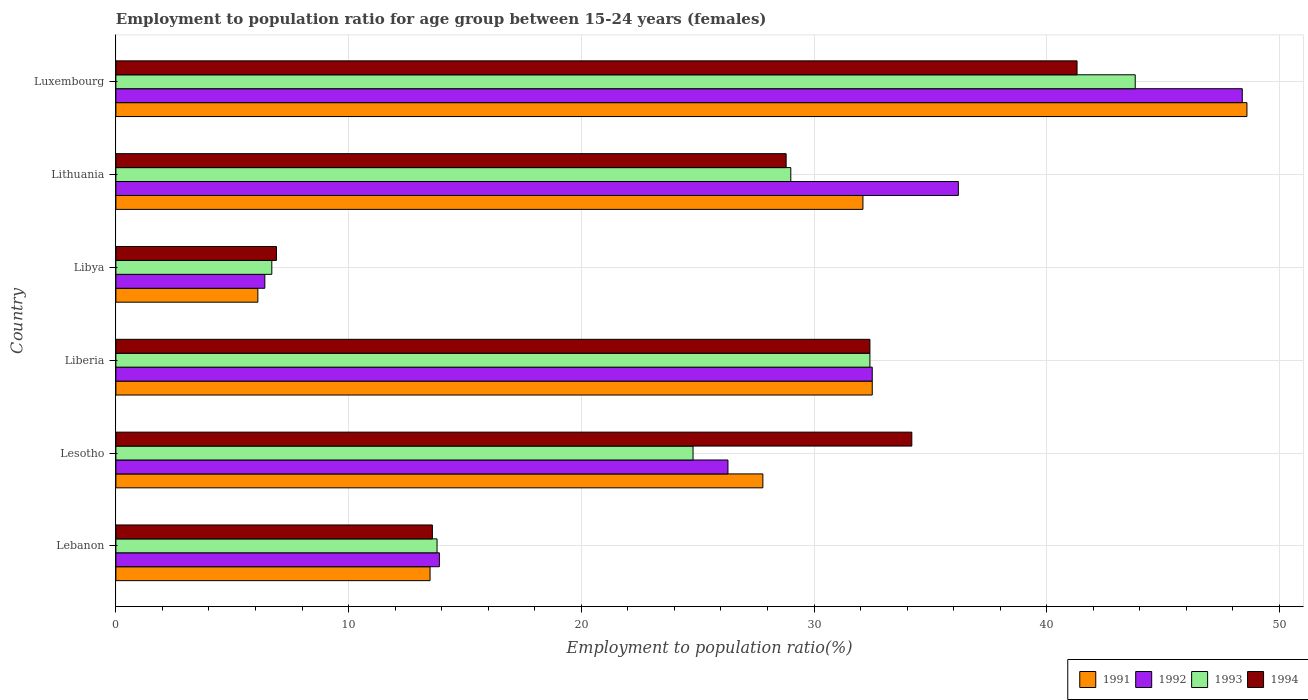How many different coloured bars are there?
Provide a short and direct response. 4. How many bars are there on the 1st tick from the top?
Your response must be concise. 4. What is the label of the 1st group of bars from the top?
Offer a very short reply. Luxembourg. In how many cases, is the number of bars for a given country not equal to the number of legend labels?
Keep it short and to the point. 0. What is the employment to population ratio in 1992 in Lebanon?
Ensure brevity in your answer.  13.9. Across all countries, what is the maximum employment to population ratio in 1993?
Your answer should be very brief. 43.8. Across all countries, what is the minimum employment to population ratio in 1991?
Ensure brevity in your answer.  6.1. In which country was the employment to population ratio in 1991 maximum?
Make the answer very short. Luxembourg. In which country was the employment to population ratio in 1992 minimum?
Your answer should be very brief. Libya. What is the total employment to population ratio in 1992 in the graph?
Give a very brief answer. 163.7. What is the difference between the employment to population ratio in 1994 in Lesotho and that in Lithuania?
Offer a very short reply. 5.4. What is the difference between the employment to population ratio in 1993 in Lesotho and the employment to population ratio in 1994 in Libya?
Keep it short and to the point. 17.9. What is the average employment to population ratio in 1991 per country?
Keep it short and to the point. 26.77. What is the ratio of the employment to population ratio in 1991 in Lebanon to that in Lesotho?
Keep it short and to the point. 0.49. What is the difference between the highest and the second highest employment to population ratio in 1992?
Provide a short and direct response. 12.2. What is the difference between the highest and the lowest employment to population ratio in 1992?
Make the answer very short. 42. In how many countries, is the employment to population ratio in 1991 greater than the average employment to population ratio in 1991 taken over all countries?
Provide a succinct answer. 4. Is the sum of the employment to population ratio in 1992 in Libya and Lithuania greater than the maximum employment to population ratio in 1994 across all countries?
Keep it short and to the point. Yes. What does the 2nd bar from the bottom in Lithuania represents?
Offer a very short reply. 1992. Is it the case that in every country, the sum of the employment to population ratio in 1991 and employment to population ratio in 1992 is greater than the employment to population ratio in 1994?
Your response must be concise. Yes. How many bars are there?
Ensure brevity in your answer.  24. Are all the bars in the graph horizontal?
Ensure brevity in your answer.  Yes. Are the values on the major ticks of X-axis written in scientific E-notation?
Ensure brevity in your answer.  No. Does the graph contain any zero values?
Provide a succinct answer. No. Where does the legend appear in the graph?
Your response must be concise. Bottom right. How many legend labels are there?
Offer a terse response. 4. What is the title of the graph?
Provide a succinct answer. Employment to population ratio for age group between 15-24 years (females). Does "2012" appear as one of the legend labels in the graph?
Your answer should be compact. No. What is the label or title of the Y-axis?
Give a very brief answer. Country. What is the Employment to population ratio(%) in 1991 in Lebanon?
Provide a short and direct response. 13.5. What is the Employment to population ratio(%) of 1992 in Lebanon?
Offer a very short reply. 13.9. What is the Employment to population ratio(%) in 1993 in Lebanon?
Give a very brief answer. 13.8. What is the Employment to population ratio(%) of 1994 in Lebanon?
Keep it short and to the point. 13.6. What is the Employment to population ratio(%) in 1991 in Lesotho?
Your answer should be compact. 27.8. What is the Employment to population ratio(%) of 1992 in Lesotho?
Offer a terse response. 26.3. What is the Employment to population ratio(%) in 1993 in Lesotho?
Your response must be concise. 24.8. What is the Employment to population ratio(%) of 1994 in Lesotho?
Your answer should be very brief. 34.2. What is the Employment to population ratio(%) in 1991 in Liberia?
Offer a terse response. 32.5. What is the Employment to population ratio(%) in 1992 in Liberia?
Give a very brief answer. 32.5. What is the Employment to population ratio(%) of 1993 in Liberia?
Keep it short and to the point. 32.4. What is the Employment to population ratio(%) in 1994 in Liberia?
Your response must be concise. 32.4. What is the Employment to population ratio(%) in 1991 in Libya?
Give a very brief answer. 6.1. What is the Employment to population ratio(%) in 1992 in Libya?
Ensure brevity in your answer.  6.4. What is the Employment to population ratio(%) of 1993 in Libya?
Your response must be concise. 6.7. What is the Employment to population ratio(%) in 1994 in Libya?
Provide a short and direct response. 6.9. What is the Employment to population ratio(%) in 1991 in Lithuania?
Keep it short and to the point. 32.1. What is the Employment to population ratio(%) of 1992 in Lithuania?
Offer a very short reply. 36.2. What is the Employment to population ratio(%) in 1993 in Lithuania?
Make the answer very short. 29. What is the Employment to population ratio(%) in 1994 in Lithuania?
Provide a succinct answer. 28.8. What is the Employment to population ratio(%) of 1991 in Luxembourg?
Your response must be concise. 48.6. What is the Employment to population ratio(%) in 1992 in Luxembourg?
Provide a succinct answer. 48.4. What is the Employment to population ratio(%) in 1993 in Luxembourg?
Keep it short and to the point. 43.8. What is the Employment to population ratio(%) of 1994 in Luxembourg?
Provide a short and direct response. 41.3. Across all countries, what is the maximum Employment to population ratio(%) in 1991?
Offer a very short reply. 48.6. Across all countries, what is the maximum Employment to population ratio(%) of 1992?
Provide a short and direct response. 48.4. Across all countries, what is the maximum Employment to population ratio(%) of 1993?
Make the answer very short. 43.8. Across all countries, what is the maximum Employment to population ratio(%) of 1994?
Your response must be concise. 41.3. Across all countries, what is the minimum Employment to population ratio(%) of 1991?
Give a very brief answer. 6.1. Across all countries, what is the minimum Employment to population ratio(%) in 1992?
Offer a very short reply. 6.4. Across all countries, what is the minimum Employment to population ratio(%) in 1993?
Make the answer very short. 6.7. Across all countries, what is the minimum Employment to population ratio(%) in 1994?
Provide a succinct answer. 6.9. What is the total Employment to population ratio(%) in 1991 in the graph?
Give a very brief answer. 160.6. What is the total Employment to population ratio(%) in 1992 in the graph?
Offer a terse response. 163.7. What is the total Employment to population ratio(%) of 1993 in the graph?
Your answer should be compact. 150.5. What is the total Employment to population ratio(%) of 1994 in the graph?
Your answer should be very brief. 157.2. What is the difference between the Employment to population ratio(%) of 1991 in Lebanon and that in Lesotho?
Your response must be concise. -14.3. What is the difference between the Employment to population ratio(%) in 1993 in Lebanon and that in Lesotho?
Offer a terse response. -11. What is the difference between the Employment to population ratio(%) of 1994 in Lebanon and that in Lesotho?
Give a very brief answer. -20.6. What is the difference between the Employment to population ratio(%) in 1992 in Lebanon and that in Liberia?
Keep it short and to the point. -18.6. What is the difference between the Employment to population ratio(%) in 1993 in Lebanon and that in Liberia?
Provide a short and direct response. -18.6. What is the difference between the Employment to population ratio(%) of 1994 in Lebanon and that in Liberia?
Offer a very short reply. -18.8. What is the difference between the Employment to population ratio(%) in 1993 in Lebanon and that in Libya?
Ensure brevity in your answer.  7.1. What is the difference between the Employment to population ratio(%) of 1991 in Lebanon and that in Lithuania?
Your answer should be compact. -18.6. What is the difference between the Employment to population ratio(%) in 1992 in Lebanon and that in Lithuania?
Your response must be concise. -22.3. What is the difference between the Employment to population ratio(%) in 1993 in Lebanon and that in Lithuania?
Offer a very short reply. -15.2. What is the difference between the Employment to population ratio(%) in 1994 in Lebanon and that in Lithuania?
Your answer should be compact. -15.2. What is the difference between the Employment to population ratio(%) of 1991 in Lebanon and that in Luxembourg?
Make the answer very short. -35.1. What is the difference between the Employment to population ratio(%) in 1992 in Lebanon and that in Luxembourg?
Your answer should be very brief. -34.5. What is the difference between the Employment to population ratio(%) in 1994 in Lebanon and that in Luxembourg?
Your response must be concise. -27.7. What is the difference between the Employment to population ratio(%) in 1991 in Lesotho and that in Libya?
Offer a terse response. 21.7. What is the difference between the Employment to population ratio(%) in 1992 in Lesotho and that in Libya?
Offer a very short reply. 19.9. What is the difference between the Employment to population ratio(%) of 1993 in Lesotho and that in Libya?
Your response must be concise. 18.1. What is the difference between the Employment to population ratio(%) in 1994 in Lesotho and that in Libya?
Your answer should be very brief. 27.3. What is the difference between the Employment to population ratio(%) of 1991 in Lesotho and that in Lithuania?
Your answer should be compact. -4.3. What is the difference between the Employment to population ratio(%) in 1992 in Lesotho and that in Lithuania?
Give a very brief answer. -9.9. What is the difference between the Employment to population ratio(%) in 1993 in Lesotho and that in Lithuania?
Your answer should be very brief. -4.2. What is the difference between the Employment to population ratio(%) of 1994 in Lesotho and that in Lithuania?
Provide a short and direct response. 5.4. What is the difference between the Employment to population ratio(%) in 1991 in Lesotho and that in Luxembourg?
Give a very brief answer. -20.8. What is the difference between the Employment to population ratio(%) of 1992 in Lesotho and that in Luxembourg?
Give a very brief answer. -22.1. What is the difference between the Employment to population ratio(%) in 1991 in Liberia and that in Libya?
Make the answer very short. 26.4. What is the difference between the Employment to population ratio(%) in 1992 in Liberia and that in Libya?
Your answer should be very brief. 26.1. What is the difference between the Employment to population ratio(%) in 1993 in Liberia and that in Libya?
Your response must be concise. 25.7. What is the difference between the Employment to population ratio(%) of 1991 in Liberia and that in Lithuania?
Offer a terse response. 0.4. What is the difference between the Employment to population ratio(%) of 1992 in Liberia and that in Lithuania?
Your response must be concise. -3.7. What is the difference between the Employment to population ratio(%) of 1994 in Liberia and that in Lithuania?
Keep it short and to the point. 3.6. What is the difference between the Employment to population ratio(%) in 1991 in Liberia and that in Luxembourg?
Your answer should be very brief. -16.1. What is the difference between the Employment to population ratio(%) of 1992 in Liberia and that in Luxembourg?
Your answer should be very brief. -15.9. What is the difference between the Employment to population ratio(%) of 1993 in Liberia and that in Luxembourg?
Give a very brief answer. -11.4. What is the difference between the Employment to population ratio(%) of 1991 in Libya and that in Lithuania?
Ensure brevity in your answer.  -26. What is the difference between the Employment to population ratio(%) of 1992 in Libya and that in Lithuania?
Make the answer very short. -29.8. What is the difference between the Employment to population ratio(%) of 1993 in Libya and that in Lithuania?
Offer a very short reply. -22.3. What is the difference between the Employment to population ratio(%) in 1994 in Libya and that in Lithuania?
Offer a terse response. -21.9. What is the difference between the Employment to population ratio(%) in 1991 in Libya and that in Luxembourg?
Keep it short and to the point. -42.5. What is the difference between the Employment to population ratio(%) in 1992 in Libya and that in Luxembourg?
Your answer should be very brief. -42. What is the difference between the Employment to population ratio(%) in 1993 in Libya and that in Luxembourg?
Your answer should be very brief. -37.1. What is the difference between the Employment to population ratio(%) in 1994 in Libya and that in Luxembourg?
Your answer should be very brief. -34.4. What is the difference between the Employment to population ratio(%) of 1991 in Lithuania and that in Luxembourg?
Give a very brief answer. -16.5. What is the difference between the Employment to population ratio(%) in 1993 in Lithuania and that in Luxembourg?
Keep it short and to the point. -14.8. What is the difference between the Employment to population ratio(%) of 1994 in Lithuania and that in Luxembourg?
Offer a very short reply. -12.5. What is the difference between the Employment to population ratio(%) in 1991 in Lebanon and the Employment to population ratio(%) in 1993 in Lesotho?
Your answer should be compact. -11.3. What is the difference between the Employment to population ratio(%) of 1991 in Lebanon and the Employment to population ratio(%) of 1994 in Lesotho?
Ensure brevity in your answer.  -20.7. What is the difference between the Employment to population ratio(%) in 1992 in Lebanon and the Employment to population ratio(%) in 1994 in Lesotho?
Your answer should be compact. -20.3. What is the difference between the Employment to population ratio(%) of 1993 in Lebanon and the Employment to population ratio(%) of 1994 in Lesotho?
Offer a terse response. -20.4. What is the difference between the Employment to population ratio(%) in 1991 in Lebanon and the Employment to population ratio(%) in 1993 in Liberia?
Ensure brevity in your answer.  -18.9. What is the difference between the Employment to population ratio(%) in 1991 in Lebanon and the Employment to population ratio(%) in 1994 in Liberia?
Your answer should be compact. -18.9. What is the difference between the Employment to population ratio(%) of 1992 in Lebanon and the Employment to population ratio(%) of 1993 in Liberia?
Your answer should be very brief. -18.5. What is the difference between the Employment to population ratio(%) of 1992 in Lebanon and the Employment to population ratio(%) of 1994 in Liberia?
Provide a succinct answer. -18.5. What is the difference between the Employment to population ratio(%) in 1993 in Lebanon and the Employment to population ratio(%) in 1994 in Liberia?
Provide a short and direct response. -18.6. What is the difference between the Employment to population ratio(%) in 1991 in Lebanon and the Employment to population ratio(%) in 1992 in Libya?
Offer a terse response. 7.1. What is the difference between the Employment to population ratio(%) in 1992 in Lebanon and the Employment to population ratio(%) in 1993 in Libya?
Give a very brief answer. 7.2. What is the difference between the Employment to population ratio(%) in 1992 in Lebanon and the Employment to population ratio(%) in 1994 in Libya?
Ensure brevity in your answer.  7. What is the difference between the Employment to population ratio(%) in 1991 in Lebanon and the Employment to population ratio(%) in 1992 in Lithuania?
Give a very brief answer. -22.7. What is the difference between the Employment to population ratio(%) in 1991 in Lebanon and the Employment to population ratio(%) in 1993 in Lithuania?
Give a very brief answer. -15.5. What is the difference between the Employment to population ratio(%) of 1991 in Lebanon and the Employment to population ratio(%) of 1994 in Lithuania?
Provide a succinct answer. -15.3. What is the difference between the Employment to population ratio(%) in 1992 in Lebanon and the Employment to population ratio(%) in 1993 in Lithuania?
Keep it short and to the point. -15.1. What is the difference between the Employment to population ratio(%) in 1992 in Lebanon and the Employment to population ratio(%) in 1994 in Lithuania?
Provide a short and direct response. -14.9. What is the difference between the Employment to population ratio(%) in 1993 in Lebanon and the Employment to population ratio(%) in 1994 in Lithuania?
Make the answer very short. -15. What is the difference between the Employment to population ratio(%) in 1991 in Lebanon and the Employment to population ratio(%) in 1992 in Luxembourg?
Provide a short and direct response. -34.9. What is the difference between the Employment to population ratio(%) of 1991 in Lebanon and the Employment to population ratio(%) of 1993 in Luxembourg?
Your answer should be compact. -30.3. What is the difference between the Employment to population ratio(%) of 1991 in Lebanon and the Employment to population ratio(%) of 1994 in Luxembourg?
Offer a very short reply. -27.8. What is the difference between the Employment to population ratio(%) in 1992 in Lebanon and the Employment to population ratio(%) in 1993 in Luxembourg?
Ensure brevity in your answer.  -29.9. What is the difference between the Employment to population ratio(%) in 1992 in Lebanon and the Employment to population ratio(%) in 1994 in Luxembourg?
Offer a very short reply. -27.4. What is the difference between the Employment to population ratio(%) in 1993 in Lebanon and the Employment to population ratio(%) in 1994 in Luxembourg?
Ensure brevity in your answer.  -27.5. What is the difference between the Employment to population ratio(%) of 1991 in Lesotho and the Employment to population ratio(%) of 1992 in Liberia?
Provide a short and direct response. -4.7. What is the difference between the Employment to population ratio(%) in 1992 in Lesotho and the Employment to population ratio(%) in 1994 in Liberia?
Provide a short and direct response. -6.1. What is the difference between the Employment to population ratio(%) of 1991 in Lesotho and the Employment to population ratio(%) of 1992 in Libya?
Ensure brevity in your answer.  21.4. What is the difference between the Employment to population ratio(%) in 1991 in Lesotho and the Employment to population ratio(%) in 1993 in Libya?
Your response must be concise. 21.1. What is the difference between the Employment to population ratio(%) in 1991 in Lesotho and the Employment to population ratio(%) in 1994 in Libya?
Your answer should be very brief. 20.9. What is the difference between the Employment to population ratio(%) of 1992 in Lesotho and the Employment to population ratio(%) of 1993 in Libya?
Keep it short and to the point. 19.6. What is the difference between the Employment to population ratio(%) of 1992 in Lesotho and the Employment to population ratio(%) of 1994 in Libya?
Offer a very short reply. 19.4. What is the difference between the Employment to population ratio(%) of 1993 in Lesotho and the Employment to population ratio(%) of 1994 in Libya?
Offer a terse response. 17.9. What is the difference between the Employment to population ratio(%) in 1991 in Lesotho and the Employment to population ratio(%) in 1992 in Lithuania?
Offer a very short reply. -8.4. What is the difference between the Employment to population ratio(%) in 1992 in Lesotho and the Employment to population ratio(%) in 1993 in Lithuania?
Your response must be concise. -2.7. What is the difference between the Employment to population ratio(%) of 1992 in Lesotho and the Employment to population ratio(%) of 1994 in Lithuania?
Your answer should be very brief. -2.5. What is the difference between the Employment to population ratio(%) in 1993 in Lesotho and the Employment to population ratio(%) in 1994 in Lithuania?
Keep it short and to the point. -4. What is the difference between the Employment to population ratio(%) of 1991 in Lesotho and the Employment to population ratio(%) of 1992 in Luxembourg?
Your answer should be compact. -20.6. What is the difference between the Employment to population ratio(%) in 1992 in Lesotho and the Employment to population ratio(%) in 1993 in Luxembourg?
Your answer should be compact. -17.5. What is the difference between the Employment to population ratio(%) in 1993 in Lesotho and the Employment to population ratio(%) in 1994 in Luxembourg?
Provide a short and direct response. -16.5. What is the difference between the Employment to population ratio(%) of 1991 in Liberia and the Employment to population ratio(%) of 1992 in Libya?
Give a very brief answer. 26.1. What is the difference between the Employment to population ratio(%) in 1991 in Liberia and the Employment to population ratio(%) in 1993 in Libya?
Make the answer very short. 25.8. What is the difference between the Employment to population ratio(%) in 1991 in Liberia and the Employment to population ratio(%) in 1994 in Libya?
Offer a terse response. 25.6. What is the difference between the Employment to population ratio(%) in 1992 in Liberia and the Employment to population ratio(%) in 1993 in Libya?
Offer a very short reply. 25.8. What is the difference between the Employment to population ratio(%) in 1992 in Liberia and the Employment to population ratio(%) in 1994 in Libya?
Offer a terse response. 25.6. What is the difference between the Employment to population ratio(%) of 1991 in Liberia and the Employment to population ratio(%) of 1992 in Lithuania?
Give a very brief answer. -3.7. What is the difference between the Employment to population ratio(%) of 1993 in Liberia and the Employment to population ratio(%) of 1994 in Lithuania?
Provide a succinct answer. 3.6. What is the difference between the Employment to population ratio(%) in 1991 in Liberia and the Employment to population ratio(%) in 1992 in Luxembourg?
Your answer should be very brief. -15.9. What is the difference between the Employment to population ratio(%) of 1991 in Liberia and the Employment to population ratio(%) of 1993 in Luxembourg?
Offer a very short reply. -11.3. What is the difference between the Employment to population ratio(%) of 1991 in Liberia and the Employment to population ratio(%) of 1994 in Luxembourg?
Your response must be concise. -8.8. What is the difference between the Employment to population ratio(%) of 1993 in Liberia and the Employment to population ratio(%) of 1994 in Luxembourg?
Offer a terse response. -8.9. What is the difference between the Employment to population ratio(%) of 1991 in Libya and the Employment to population ratio(%) of 1992 in Lithuania?
Provide a succinct answer. -30.1. What is the difference between the Employment to population ratio(%) of 1991 in Libya and the Employment to population ratio(%) of 1993 in Lithuania?
Your response must be concise. -22.9. What is the difference between the Employment to population ratio(%) of 1991 in Libya and the Employment to population ratio(%) of 1994 in Lithuania?
Provide a succinct answer. -22.7. What is the difference between the Employment to population ratio(%) of 1992 in Libya and the Employment to population ratio(%) of 1993 in Lithuania?
Keep it short and to the point. -22.6. What is the difference between the Employment to population ratio(%) of 1992 in Libya and the Employment to population ratio(%) of 1994 in Lithuania?
Provide a short and direct response. -22.4. What is the difference between the Employment to population ratio(%) of 1993 in Libya and the Employment to population ratio(%) of 1994 in Lithuania?
Make the answer very short. -22.1. What is the difference between the Employment to population ratio(%) in 1991 in Libya and the Employment to population ratio(%) in 1992 in Luxembourg?
Give a very brief answer. -42.3. What is the difference between the Employment to population ratio(%) of 1991 in Libya and the Employment to population ratio(%) of 1993 in Luxembourg?
Provide a succinct answer. -37.7. What is the difference between the Employment to population ratio(%) in 1991 in Libya and the Employment to population ratio(%) in 1994 in Luxembourg?
Give a very brief answer. -35.2. What is the difference between the Employment to population ratio(%) of 1992 in Libya and the Employment to population ratio(%) of 1993 in Luxembourg?
Offer a very short reply. -37.4. What is the difference between the Employment to population ratio(%) of 1992 in Libya and the Employment to population ratio(%) of 1994 in Luxembourg?
Make the answer very short. -34.9. What is the difference between the Employment to population ratio(%) of 1993 in Libya and the Employment to population ratio(%) of 1994 in Luxembourg?
Offer a very short reply. -34.6. What is the difference between the Employment to population ratio(%) of 1991 in Lithuania and the Employment to population ratio(%) of 1992 in Luxembourg?
Your answer should be compact. -16.3. What is the difference between the Employment to population ratio(%) of 1991 in Lithuania and the Employment to population ratio(%) of 1993 in Luxembourg?
Offer a very short reply. -11.7. What is the average Employment to population ratio(%) in 1991 per country?
Keep it short and to the point. 26.77. What is the average Employment to population ratio(%) in 1992 per country?
Your response must be concise. 27.28. What is the average Employment to population ratio(%) of 1993 per country?
Give a very brief answer. 25.08. What is the average Employment to population ratio(%) in 1994 per country?
Provide a short and direct response. 26.2. What is the difference between the Employment to population ratio(%) of 1991 and Employment to population ratio(%) of 1994 in Lebanon?
Ensure brevity in your answer.  -0.1. What is the difference between the Employment to population ratio(%) of 1992 and Employment to population ratio(%) of 1994 in Lebanon?
Offer a terse response. 0.3. What is the difference between the Employment to population ratio(%) of 1991 and Employment to population ratio(%) of 1994 in Lesotho?
Make the answer very short. -6.4. What is the difference between the Employment to population ratio(%) of 1991 and Employment to population ratio(%) of 1994 in Liberia?
Give a very brief answer. 0.1. What is the difference between the Employment to population ratio(%) of 1992 and Employment to population ratio(%) of 1993 in Liberia?
Your answer should be very brief. 0.1. What is the difference between the Employment to population ratio(%) in 1991 and Employment to population ratio(%) in 1992 in Libya?
Your response must be concise. -0.3. What is the difference between the Employment to population ratio(%) of 1991 and Employment to population ratio(%) of 1993 in Libya?
Your response must be concise. -0.6. What is the difference between the Employment to population ratio(%) in 1991 and Employment to population ratio(%) in 1994 in Libya?
Keep it short and to the point. -0.8. What is the difference between the Employment to population ratio(%) in 1991 and Employment to population ratio(%) in 1992 in Lithuania?
Provide a succinct answer. -4.1. What is the difference between the Employment to population ratio(%) of 1991 and Employment to population ratio(%) of 1993 in Lithuania?
Keep it short and to the point. 3.1. What is the difference between the Employment to population ratio(%) of 1991 and Employment to population ratio(%) of 1994 in Lithuania?
Your answer should be very brief. 3.3. What is the difference between the Employment to population ratio(%) in 1992 and Employment to population ratio(%) in 1994 in Lithuania?
Offer a terse response. 7.4. What is the difference between the Employment to population ratio(%) of 1993 and Employment to population ratio(%) of 1994 in Lithuania?
Make the answer very short. 0.2. What is the difference between the Employment to population ratio(%) in 1991 and Employment to population ratio(%) in 1994 in Luxembourg?
Ensure brevity in your answer.  7.3. What is the difference between the Employment to population ratio(%) in 1992 and Employment to population ratio(%) in 1994 in Luxembourg?
Your response must be concise. 7.1. What is the ratio of the Employment to population ratio(%) in 1991 in Lebanon to that in Lesotho?
Keep it short and to the point. 0.49. What is the ratio of the Employment to population ratio(%) of 1992 in Lebanon to that in Lesotho?
Your answer should be compact. 0.53. What is the ratio of the Employment to population ratio(%) in 1993 in Lebanon to that in Lesotho?
Offer a terse response. 0.56. What is the ratio of the Employment to population ratio(%) of 1994 in Lebanon to that in Lesotho?
Ensure brevity in your answer.  0.4. What is the ratio of the Employment to population ratio(%) of 1991 in Lebanon to that in Liberia?
Make the answer very short. 0.42. What is the ratio of the Employment to population ratio(%) of 1992 in Lebanon to that in Liberia?
Your response must be concise. 0.43. What is the ratio of the Employment to population ratio(%) of 1993 in Lebanon to that in Liberia?
Your answer should be compact. 0.43. What is the ratio of the Employment to population ratio(%) of 1994 in Lebanon to that in Liberia?
Provide a short and direct response. 0.42. What is the ratio of the Employment to population ratio(%) in 1991 in Lebanon to that in Libya?
Your response must be concise. 2.21. What is the ratio of the Employment to population ratio(%) in 1992 in Lebanon to that in Libya?
Your answer should be very brief. 2.17. What is the ratio of the Employment to population ratio(%) in 1993 in Lebanon to that in Libya?
Provide a succinct answer. 2.06. What is the ratio of the Employment to population ratio(%) in 1994 in Lebanon to that in Libya?
Ensure brevity in your answer.  1.97. What is the ratio of the Employment to population ratio(%) of 1991 in Lebanon to that in Lithuania?
Keep it short and to the point. 0.42. What is the ratio of the Employment to population ratio(%) of 1992 in Lebanon to that in Lithuania?
Offer a terse response. 0.38. What is the ratio of the Employment to population ratio(%) of 1993 in Lebanon to that in Lithuania?
Provide a short and direct response. 0.48. What is the ratio of the Employment to population ratio(%) of 1994 in Lebanon to that in Lithuania?
Offer a very short reply. 0.47. What is the ratio of the Employment to population ratio(%) of 1991 in Lebanon to that in Luxembourg?
Offer a terse response. 0.28. What is the ratio of the Employment to population ratio(%) of 1992 in Lebanon to that in Luxembourg?
Ensure brevity in your answer.  0.29. What is the ratio of the Employment to population ratio(%) in 1993 in Lebanon to that in Luxembourg?
Make the answer very short. 0.32. What is the ratio of the Employment to population ratio(%) in 1994 in Lebanon to that in Luxembourg?
Give a very brief answer. 0.33. What is the ratio of the Employment to population ratio(%) in 1991 in Lesotho to that in Liberia?
Give a very brief answer. 0.86. What is the ratio of the Employment to population ratio(%) in 1992 in Lesotho to that in Liberia?
Keep it short and to the point. 0.81. What is the ratio of the Employment to population ratio(%) of 1993 in Lesotho to that in Liberia?
Your response must be concise. 0.77. What is the ratio of the Employment to population ratio(%) in 1994 in Lesotho to that in Liberia?
Give a very brief answer. 1.06. What is the ratio of the Employment to population ratio(%) of 1991 in Lesotho to that in Libya?
Offer a terse response. 4.56. What is the ratio of the Employment to population ratio(%) of 1992 in Lesotho to that in Libya?
Your response must be concise. 4.11. What is the ratio of the Employment to population ratio(%) in 1993 in Lesotho to that in Libya?
Ensure brevity in your answer.  3.7. What is the ratio of the Employment to population ratio(%) in 1994 in Lesotho to that in Libya?
Offer a terse response. 4.96. What is the ratio of the Employment to population ratio(%) of 1991 in Lesotho to that in Lithuania?
Give a very brief answer. 0.87. What is the ratio of the Employment to population ratio(%) in 1992 in Lesotho to that in Lithuania?
Provide a short and direct response. 0.73. What is the ratio of the Employment to population ratio(%) in 1993 in Lesotho to that in Lithuania?
Give a very brief answer. 0.86. What is the ratio of the Employment to population ratio(%) in 1994 in Lesotho to that in Lithuania?
Provide a short and direct response. 1.19. What is the ratio of the Employment to population ratio(%) in 1991 in Lesotho to that in Luxembourg?
Give a very brief answer. 0.57. What is the ratio of the Employment to population ratio(%) of 1992 in Lesotho to that in Luxembourg?
Provide a short and direct response. 0.54. What is the ratio of the Employment to population ratio(%) of 1993 in Lesotho to that in Luxembourg?
Make the answer very short. 0.57. What is the ratio of the Employment to population ratio(%) in 1994 in Lesotho to that in Luxembourg?
Your answer should be compact. 0.83. What is the ratio of the Employment to population ratio(%) of 1991 in Liberia to that in Libya?
Ensure brevity in your answer.  5.33. What is the ratio of the Employment to population ratio(%) of 1992 in Liberia to that in Libya?
Provide a succinct answer. 5.08. What is the ratio of the Employment to population ratio(%) in 1993 in Liberia to that in Libya?
Provide a succinct answer. 4.84. What is the ratio of the Employment to population ratio(%) of 1994 in Liberia to that in Libya?
Offer a terse response. 4.7. What is the ratio of the Employment to population ratio(%) of 1991 in Liberia to that in Lithuania?
Make the answer very short. 1.01. What is the ratio of the Employment to population ratio(%) in 1992 in Liberia to that in Lithuania?
Offer a terse response. 0.9. What is the ratio of the Employment to population ratio(%) of 1993 in Liberia to that in Lithuania?
Provide a short and direct response. 1.12. What is the ratio of the Employment to population ratio(%) in 1994 in Liberia to that in Lithuania?
Your answer should be very brief. 1.12. What is the ratio of the Employment to population ratio(%) in 1991 in Liberia to that in Luxembourg?
Your response must be concise. 0.67. What is the ratio of the Employment to population ratio(%) in 1992 in Liberia to that in Luxembourg?
Provide a succinct answer. 0.67. What is the ratio of the Employment to population ratio(%) of 1993 in Liberia to that in Luxembourg?
Your response must be concise. 0.74. What is the ratio of the Employment to population ratio(%) of 1994 in Liberia to that in Luxembourg?
Give a very brief answer. 0.78. What is the ratio of the Employment to population ratio(%) in 1991 in Libya to that in Lithuania?
Provide a short and direct response. 0.19. What is the ratio of the Employment to population ratio(%) in 1992 in Libya to that in Lithuania?
Keep it short and to the point. 0.18. What is the ratio of the Employment to population ratio(%) of 1993 in Libya to that in Lithuania?
Make the answer very short. 0.23. What is the ratio of the Employment to population ratio(%) in 1994 in Libya to that in Lithuania?
Ensure brevity in your answer.  0.24. What is the ratio of the Employment to population ratio(%) of 1991 in Libya to that in Luxembourg?
Offer a terse response. 0.13. What is the ratio of the Employment to population ratio(%) in 1992 in Libya to that in Luxembourg?
Your response must be concise. 0.13. What is the ratio of the Employment to population ratio(%) in 1993 in Libya to that in Luxembourg?
Your response must be concise. 0.15. What is the ratio of the Employment to population ratio(%) in 1994 in Libya to that in Luxembourg?
Keep it short and to the point. 0.17. What is the ratio of the Employment to population ratio(%) of 1991 in Lithuania to that in Luxembourg?
Provide a succinct answer. 0.66. What is the ratio of the Employment to population ratio(%) of 1992 in Lithuania to that in Luxembourg?
Provide a succinct answer. 0.75. What is the ratio of the Employment to population ratio(%) of 1993 in Lithuania to that in Luxembourg?
Provide a short and direct response. 0.66. What is the ratio of the Employment to population ratio(%) of 1994 in Lithuania to that in Luxembourg?
Your answer should be very brief. 0.7. What is the difference between the highest and the second highest Employment to population ratio(%) of 1991?
Keep it short and to the point. 16.1. What is the difference between the highest and the second highest Employment to population ratio(%) of 1993?
Offer a terse response. 11.4. What is the difference between the highest and the second highest Employment to population ratio(%) in 1994?
Offer a very short reply. 7.1. What is the difference between the highest and the lowest Employment to population ratio(%) of 1991?
Provide a succinct answer. 42.5. What is the difference between the highest and the lowest Employment to population ratio(%) in 1993?
Offer a terse response. 37.1. What is the difference between the highest and the lowest Employment to population ratio(%) of 1994?
Offer a very short reply. 34.4. 